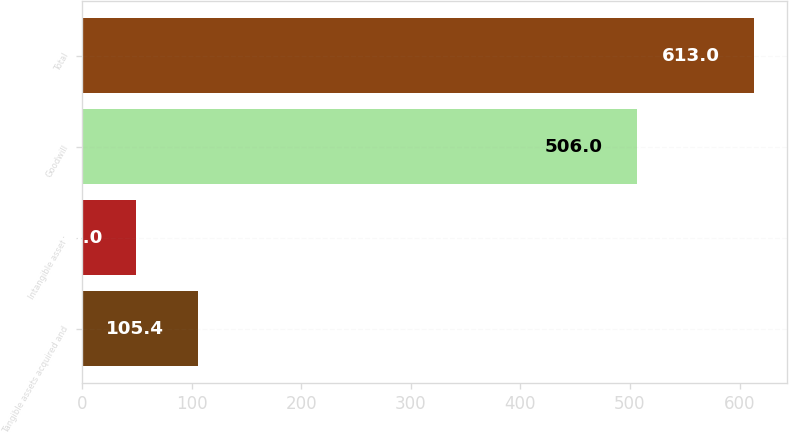Convert chart. <chart><loc_0><loc_0><loc_500><loc_500><bar_chart><fcel>Tangible assets acquired and<fcel>Intangible assets<fcel>Goodwill<fcel>Total<nl><fcel>105.4<fcel>49<fcel>506<fcel>613<nl></chart> 